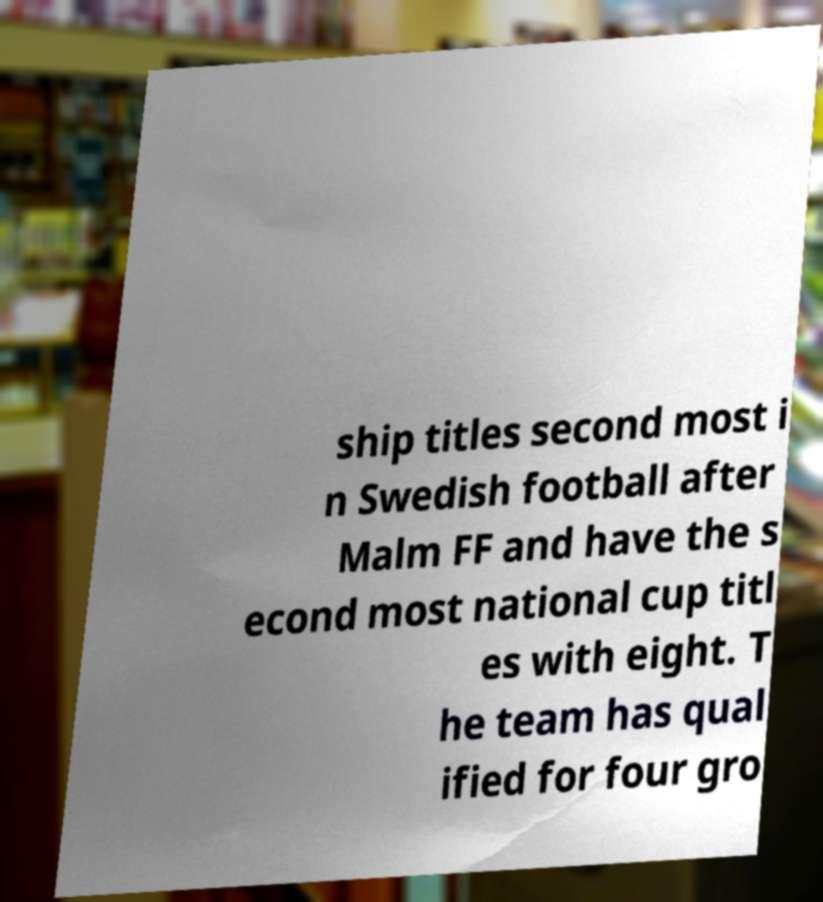Could you extract and type out the text from this image? ship titles second most i n Swedish football after Malm FF and have the s econd most national cup titl es with eight. T he team has qual ified for four gro 